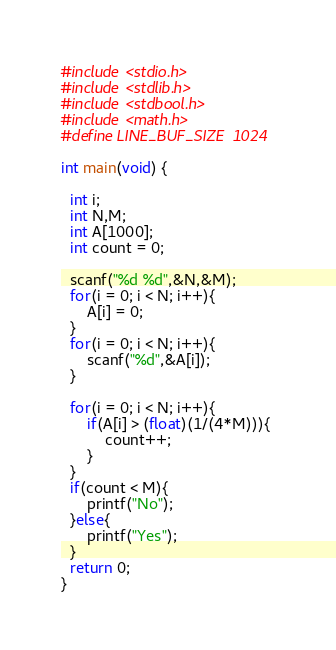Convert code to text. <code><loc_0><loc_0><loc_500><loc_500><_C_>#include <stdio.h>
#include <stdlib.h>
#include <stdbool.h>
#include <math.h>
#define LINE_BUF_SIZE  1024

int main(void) {
  
  int i;
  int N,M;
  int A[1000];
  int count = 0;

  scanf("%d %d",&N,&M);
  for(i = 0; i < N; i++){
      A[i] = 0;
  }
  for(i = 0; i < N; i++){
      scanf("%d",&A[i]);
  }
  
  for(i = 0; i < N; i++){
      if(A[i] > (float)(1/(4*M))){
          count++;          
      }
  }
  if(count < M){
      printf("No");
  }else{
      printf("Yes");
  }
  return 0;
}</code> 